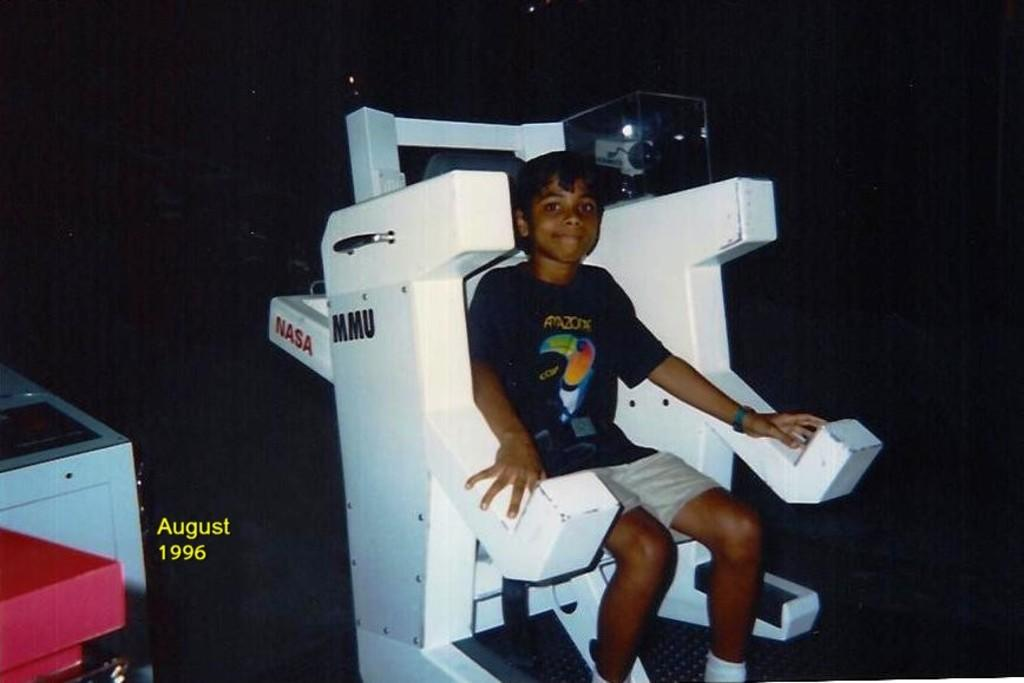Who is the main subject in the image? There is a boy in the image. What is the boy sitting on? The boy is sitting on a manned maneuvering unit. What else can be seen in the image besides the boy? There is a machine in the image. What is the color of the background in the image? The background of the image is dark. What type of reward is the boy holding in the image? There is no reward visible in the image; the boy is sitting on a manned maneuvering unit and there is a machine in the background. How many pigs are present in the image? There are no pigs present in the image. 